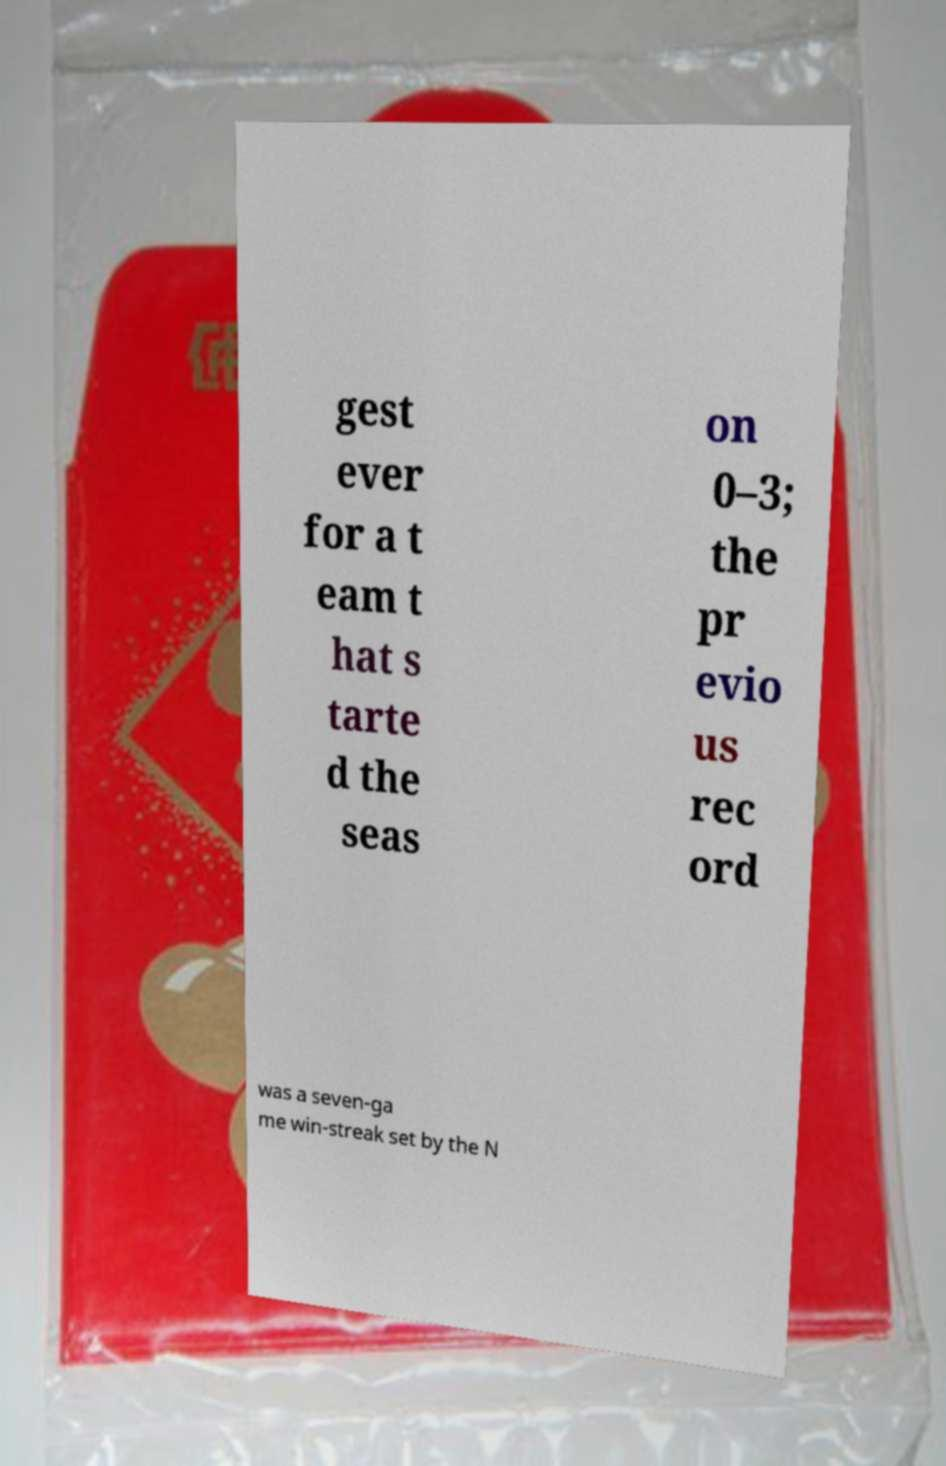For documentation purposes, I need the text within this image transcribed. Could you provide that? gest ever for a t eam t hat s tarte d the seas on 0–3; the pr evio us rec ord was a seven-ga me win-streak set by the N 